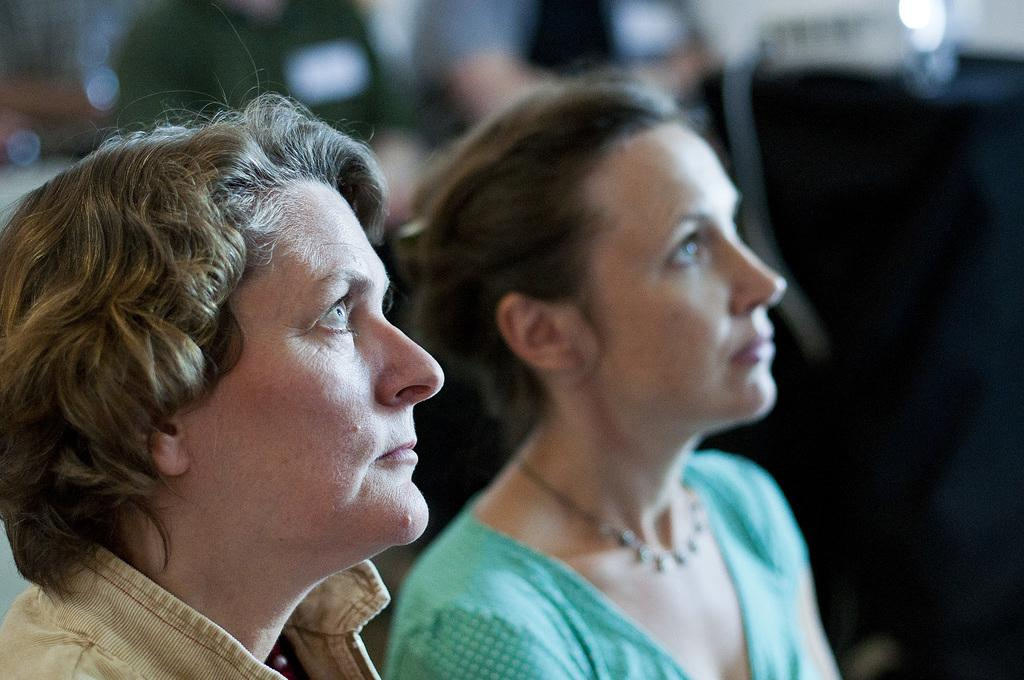How many people are in the image? The number of people in the image cannot be determined from the provided fact. What type of parcel is being delivered by the person driving a car in the image? There is no information about a parcel or a person driving a car in the image, as only one fact is provided. 